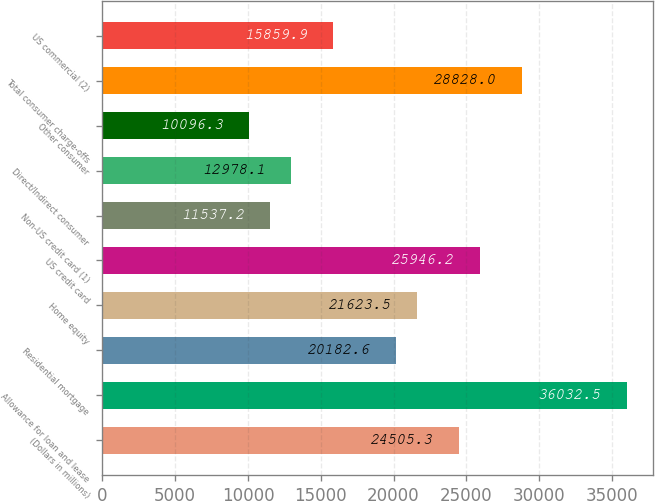Convert chart. <chart><loc_0><loc_0><loc_500><loc_500><bar_chart><fcel>(Dollars in millions)<fcel>Allowance for loan and lease<fcel>Residential mortgage<fcel>Home equity<fcel>US credit card<fcel>Non-US credit card (1)<fcel>Direct/Indirect consumer<fcel>Other consumer<fcel>Total consumer charge-offs<fcel>US commercial (2)<nl><fcel>24505.3<fcel>36032.5<fcel>20182.6<fcel>21623.5<fcel>25946.2<fcel>11537.2<fcel>12978.1<fcel>10096.3<fcel>28828<fcel>15859.9<nl></chart> 